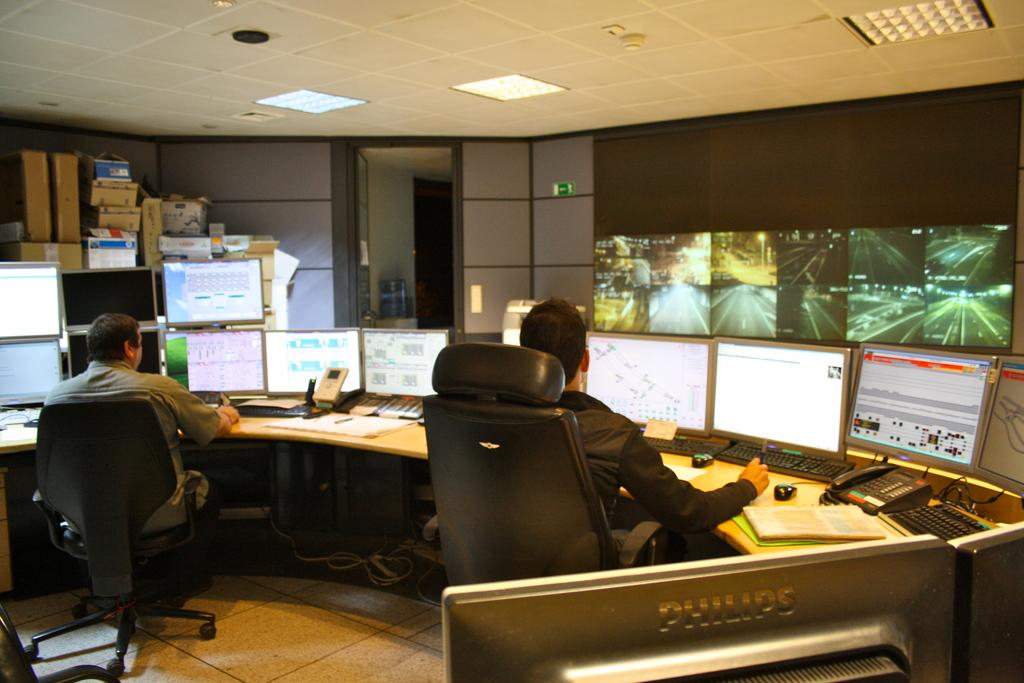Where is the setting of the image? The image is inside a room. What furniture is present in the room? There is a table in the room. What electronic devices are on the table? Monitors, keyboards, and mouses are on the table. What else is on the table? Books and a telephone are on the table. What is on the wall? There is a screen on the wall. What additional items are in the room? Cardboard boxes are in the room. How many people are in the room? Two persons are sitting on chairs in the room. How many oranges are on the table in the image? There are no oranges present on the table in the image. What type of house is depicted in the image? The image does not depict a house; it is inside a room. 